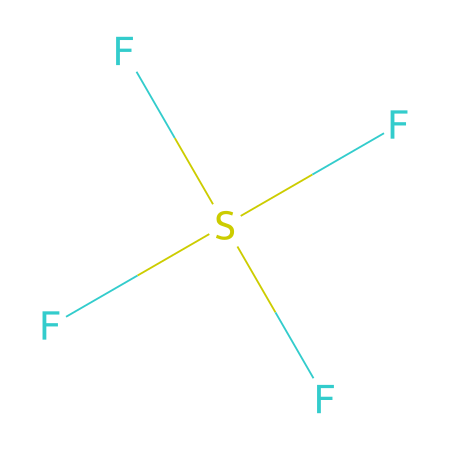What is the molecular formula of sulfur tetrafluoride? The SMILES representation indicates that the compound consists of one sulfur atom and four fluorine atoms. Thus, the molecular formula can be derived from counting the number of each type of atom present.
Answer: SF4 How many bonds does the sulfur atom form in SF4? In the structure represented by the SMILES, the sulfur is bonded to four fluorine atoms, which signifies that it forms four bonds in total.
Answer: 4 What type of hybridization does sulfur in SF4 exhibit? To determine the hybridization of sulfur, we analyze the number of bonded atoms and lone pairs. Since sulfur is connected to four fluorine atoms and has one lone pair, it either uses sp3d hybridization to accommodate the five regions of electron density.
Answer: sp3d Describe the geometry of the SF4 molecule. Given the four bonded fluorine atoms and one lone pair around the sulfur atom, the geometry can be assessed to be seesaw due to the arrangement of the electrons. The lone pair occupies an equatorial position, while the fluorines are arranged in a distorted tetrahedral manner.
Answer: seesaw Why is sulfur tetrafluoride considered a hypervalent compound? Hypervalency refers to compounds that exhibit more than eight valence electrons around their central atom. SF4 demonstrates this as sulfur has 10 valence electrons when accounting for its bonds with four fluorine atoms and one lone pair.
Answer: ten What role does SF4 play in chemical reactions? In chemical reactions, SF4 is primarily used for fluorination processes, where it acts as a fluorinating agent to introduce fluorine atoms into other compounds, highlighting its utility in organic synthesis and modification of materials.
Answer: fluorinating agent 